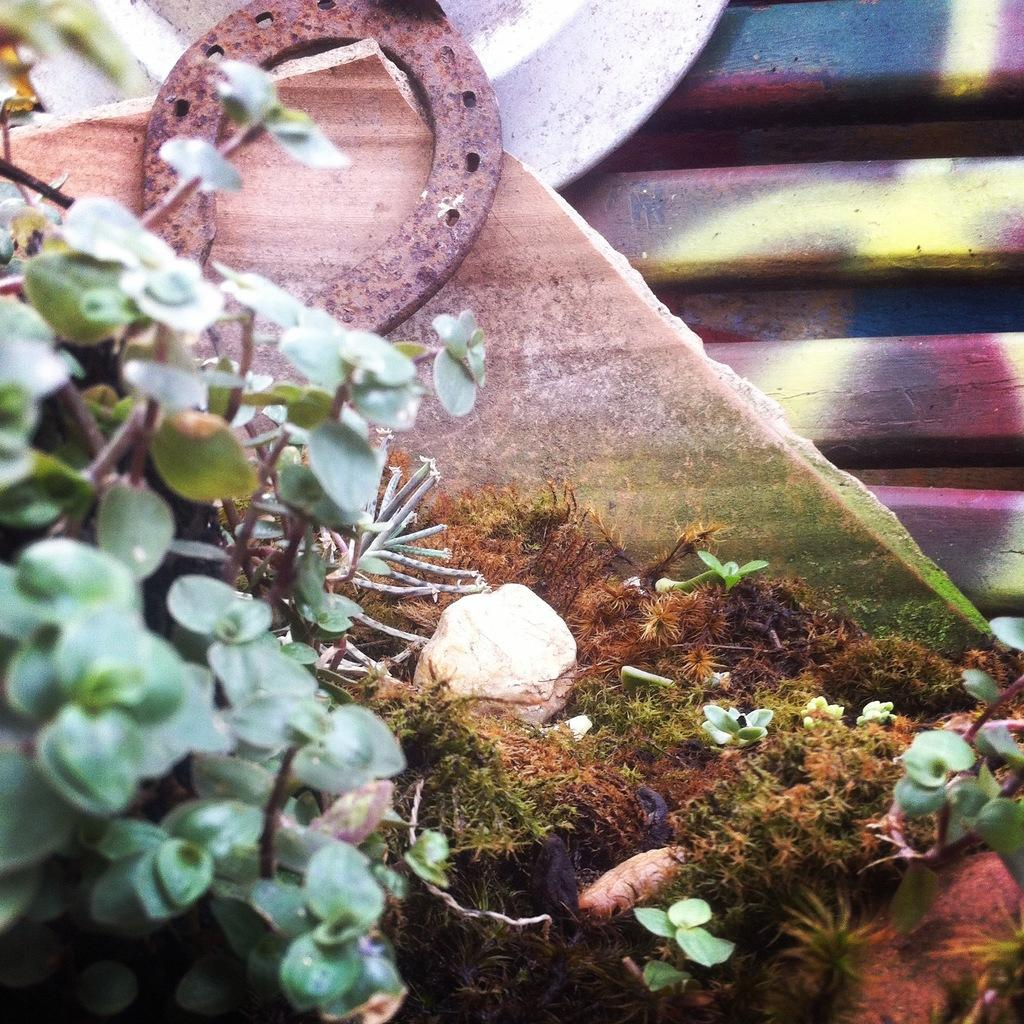What type of living organisms can be seen in the image? Plants are visible in the image. What is the non-living object made of in the image? There is a stone in the image. What type of decorative item can be seen in the image? There is a marble piece in the image. What is the condition of one of the items in the image? There is a rusted item in the image. Can you describe any other objects in the image? There are other items in the image, but their specific details are not mentioned in the provided facts. What type of train can be seen in the image? There is no train present in the image. How many pigs are visible in the image? There are no pigs visible in the image. 